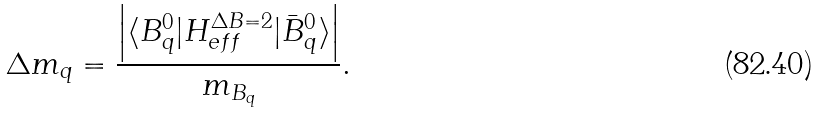Convert formula to latex. <formula><loc_0><loc_0><loc_500><loc_500>\Delta m _ { q } = \frac { \left | \langle B ^ { 0 } _ { q } | H _ { e f f } ^ { \Delta B = 2 } | { \bar { B } } ^ { 0 } _ { q } \rangle \right | } { m _ { B _ { q } } } .</formula> 